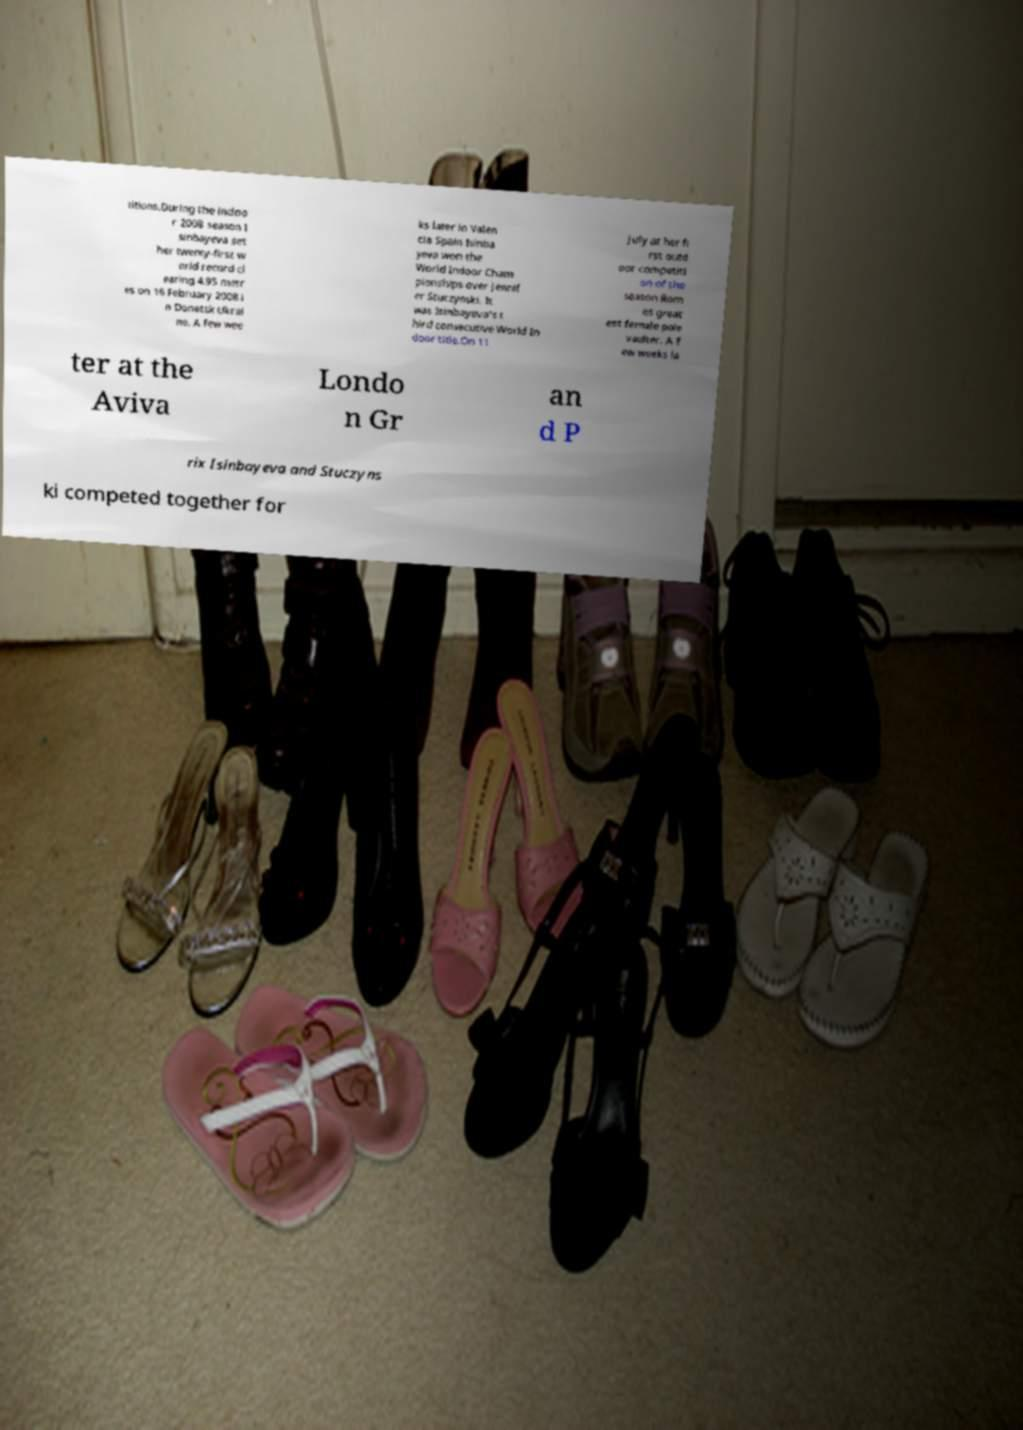Could you extract and type out the text from this image? titions.During the indoo r 2008 season I sinbayeva set her twenty-first w orld record cl earing 4.95 metr es on 16 February 2008 i n Donetsk Ukrai ne. A few wee ks later in Valen cia Spain Isinba yeva won the World Indoor Cham pionships over Jennif er Stuczynski. It was Isinbayeva's t hird consecutive World In door title.On 11 July at her fi rst outd oor competiti on of the season Rom es great est female pole vaulter. A f ew weeks la ter at the Aviva Londo n Gr an d P rix Isinbayeva and Stuczyns ki competed together for 